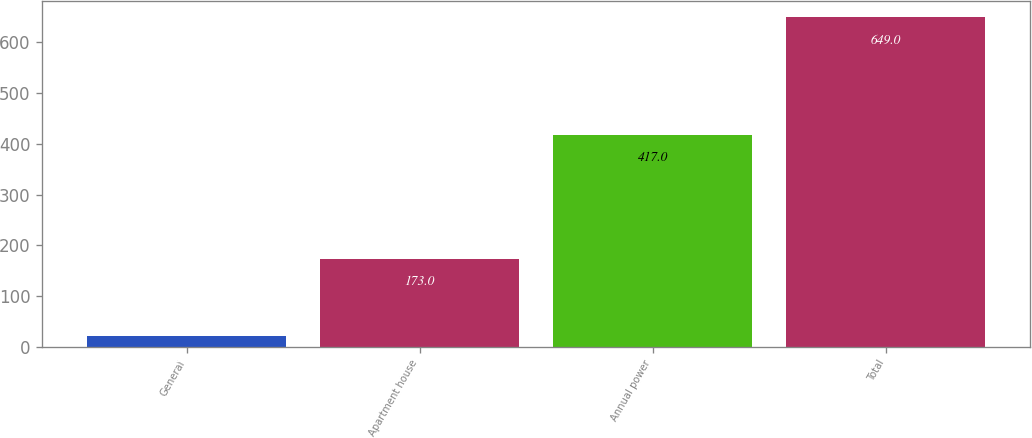Convert chart. <chart><loc_0><loc_0><loc_500><loc_500><bar_chart><fcel>General<fcel>Apartment house<fcel>Annual power<fcel>Total<nl><fcel>22<fcel>173<fcel>417<fcel>649<nl></chart> 